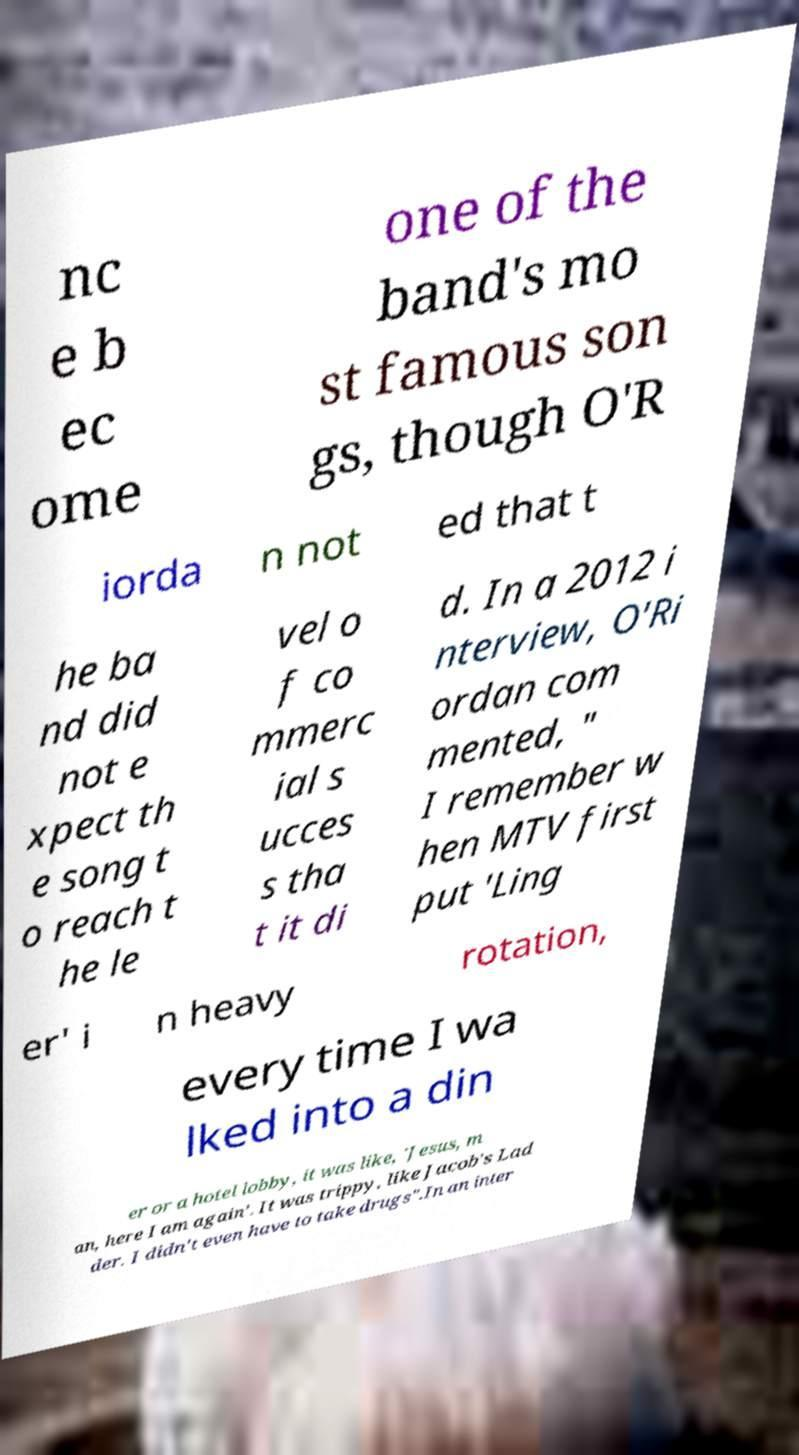I need the written content from this picture converted into text. Can you do that? nc e b ec ome one of the band's mo st famous son gs, though O'R iorda n not ed that t he ba nd did not e xpect th e song t o reach t he le vel o f co mmerc ial s ucces s tha t it di d. In a 2012 i nterview, O'Ri ordan com mented, " I remember w hen MTV first put 'Ling er' i n heavy rotation, every time I wa lked into a din er or a hotel lobby, it was like, 'Jesus, m an, here I am again'. It was trippy, like Jacob's Lad der. I didn't even have to take drugs".In an inter 